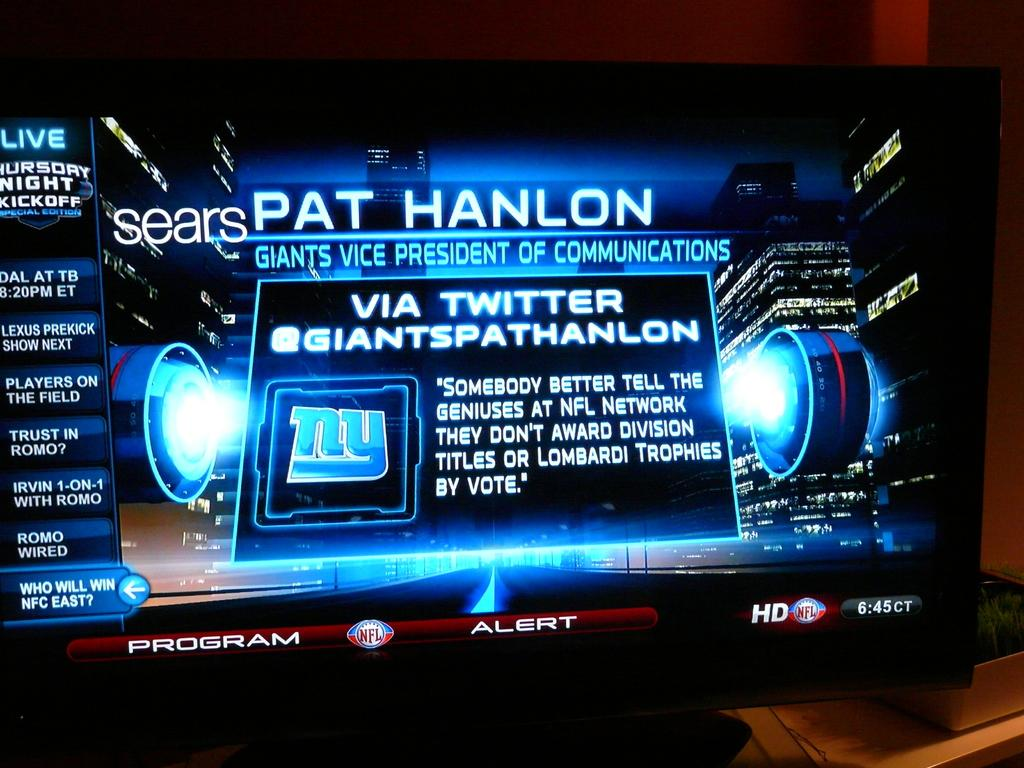<image>
Present a compact description of the photo's key features. A small monitor has the name Pat Hanlon on the top of an information page. 